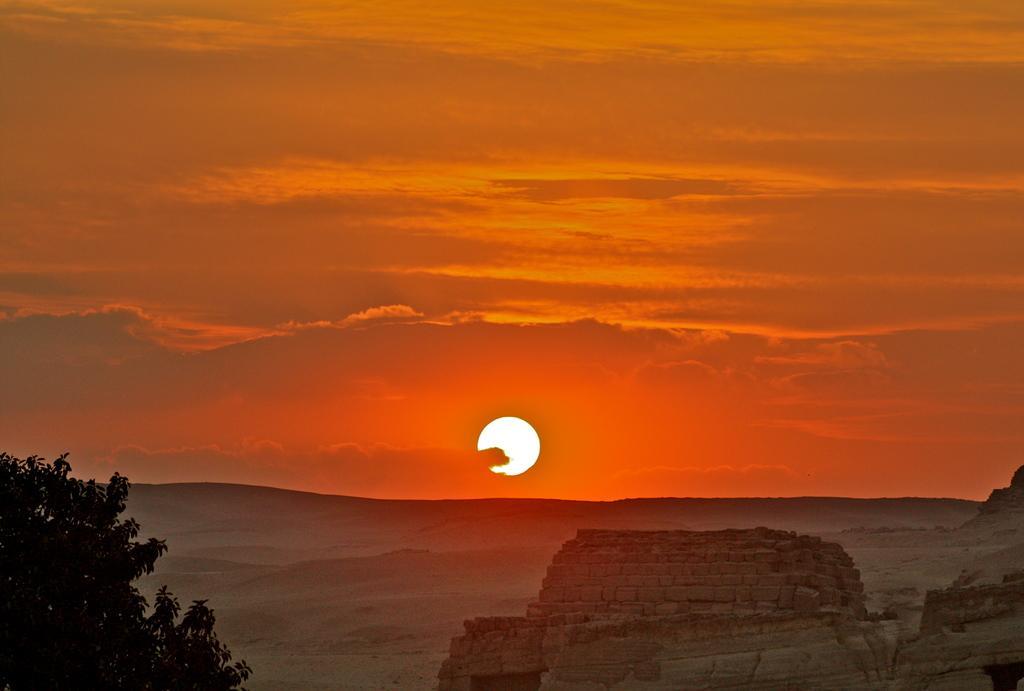How would you summarize this image in a sentence or two? In this picture, we can see mountains, tree in the bottom left corner, and we can see the ground, the sky with clouds and the sun. 